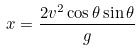Convert formula to latex. <formula><loc_0><loc_0><loc_500><loc_500>x = \frac { 2 v ^ { 2 } \cos \theta \sin \theta } { g }</formula> 